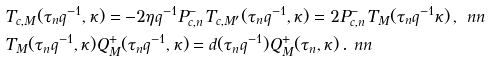Convert formula to latex. <formula><loc_0><loc_0><loc_500><loc_500>& T _ { c , M } ( \tau _ { n } q ^ { - 1 } , \kappa ) = - 2 \eta q ^ { - 1 } P ^ { - } _ { c , n } T _ { c , M ^ { \prime } } ( \tau _ { n } q ^ { - 1 } , \kappa ) = 2 P ^ { - } _ { c , n } T _ { M } ( \tau _ { n } q ^ { - 1 } \kappa ) \, , \ n n \\ & T _ { M } ( \tau _ { n } q ^ { - 1 } , \kappa ) Q ^ { + } _ { M } ( \tau _ { n } q ^ { - 1 } , \kappa ) = d ( \tau _ { n } q ^ { - 1 } ) Q ^ { + } _ { M } ( \tau _ { n } , \kappa ) \, . \ n n</formula> 